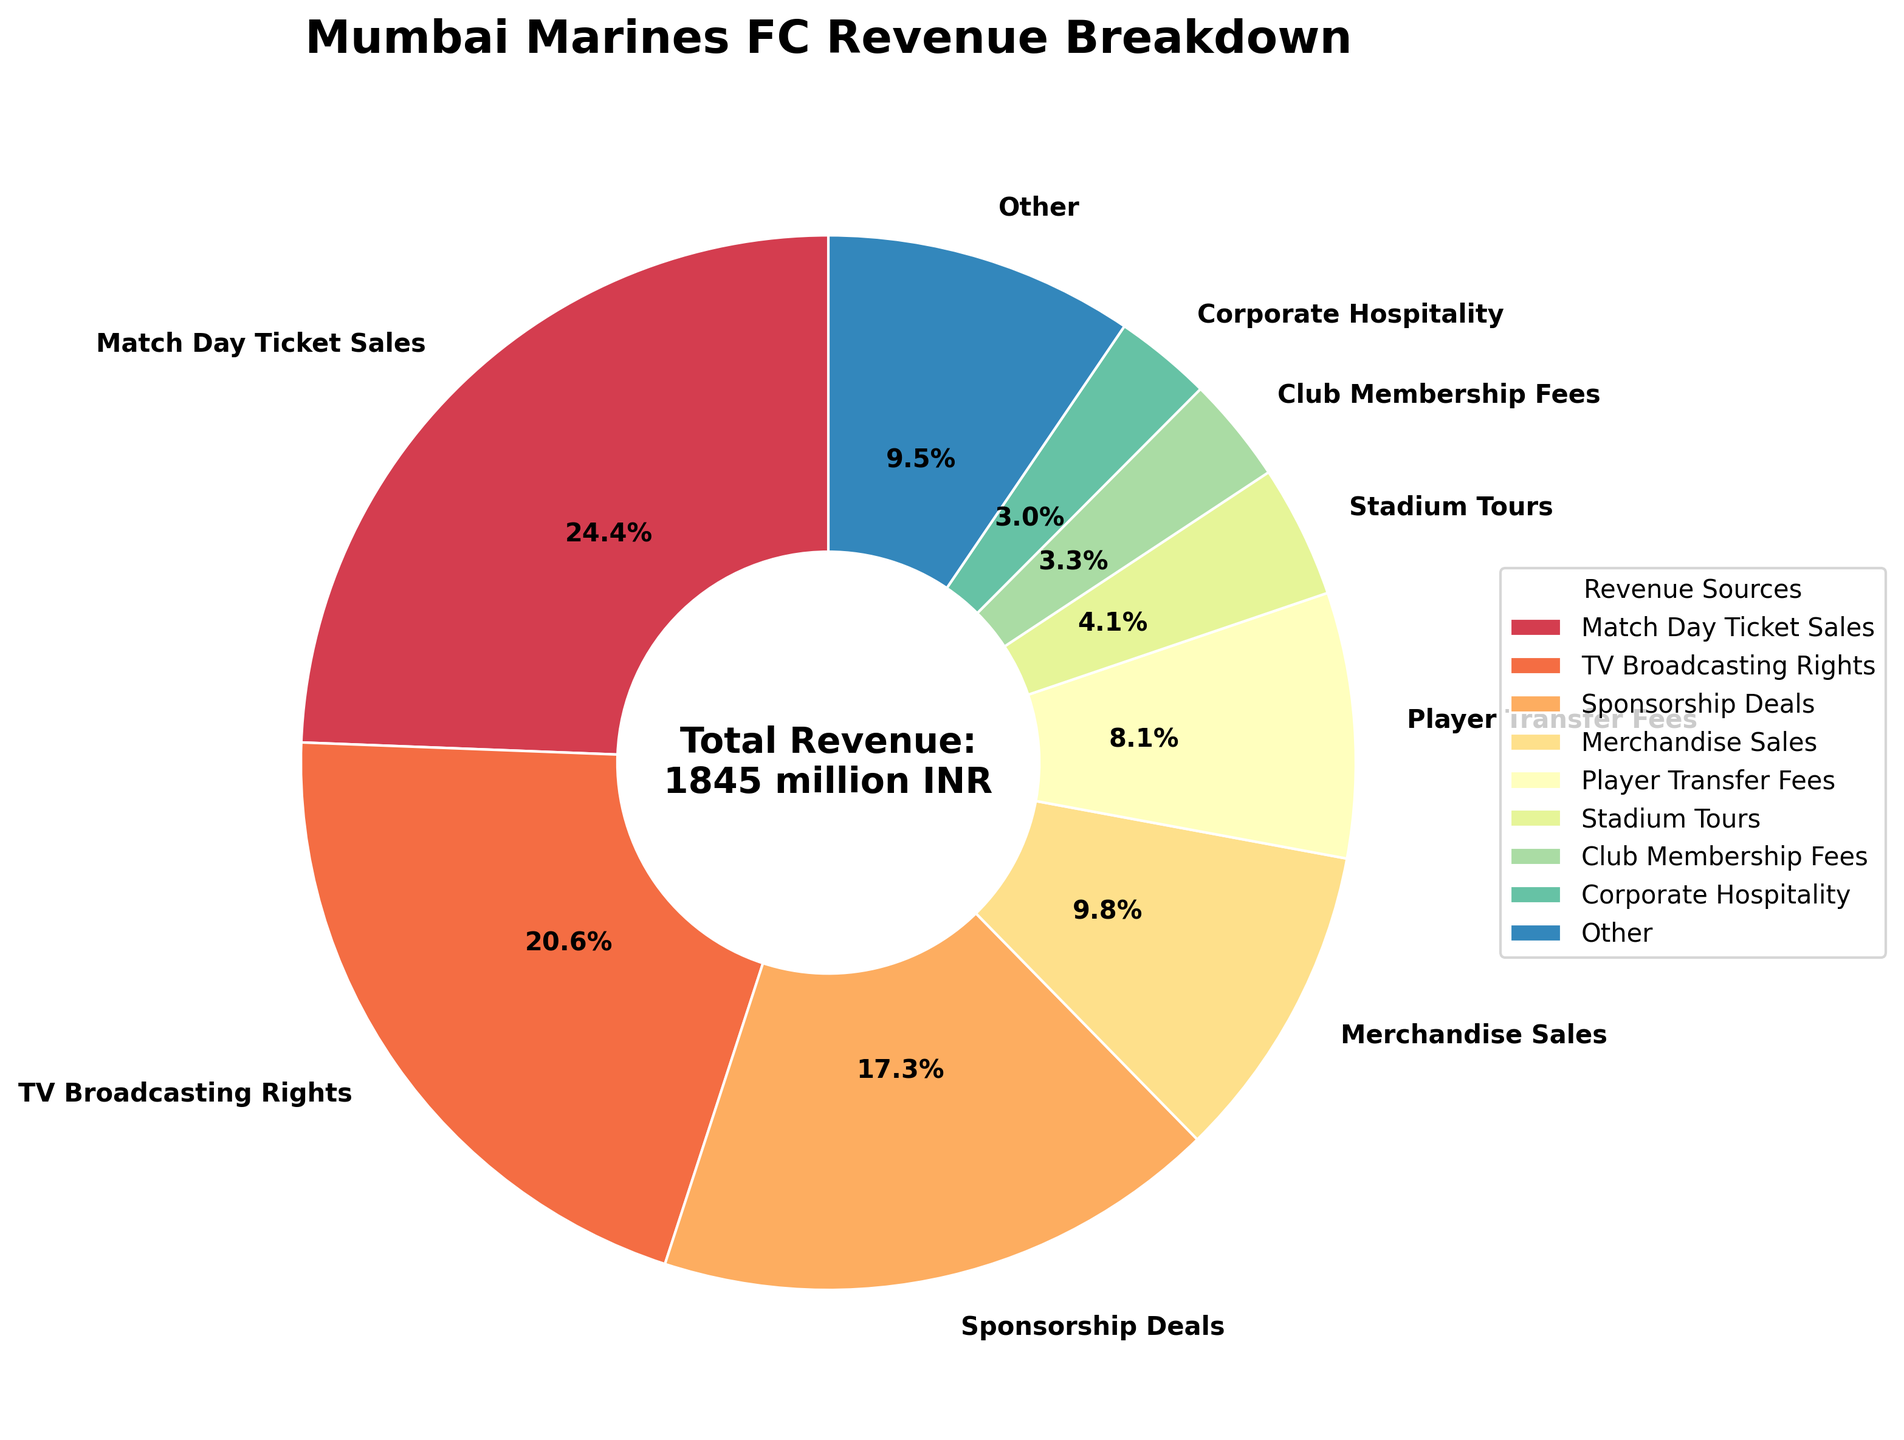Which revenue source contributes the largest percentage? The section with the largest percentage on the pie chart is Match Day Ticket Sales. It occupies the biggest wedge on the pie chart.
Answer: Match Day Ticket Sales Which revenue source has a larger contribution, Merchandise Sales or TV Broadcasting Rights? By comparing their sections on the pie chart, TV Broadcasting Rights has a larger wedge than Merchandise Sales.
Answer: TV Broadcasting Rights What percentage of the total revenue is generated by Social Media Partnerships and Esports Team Revenue combined? Social Media Partnerships contribute 1.8%, and Esports Team Revenue contributes 1.3%. Adding these percentages gives 3.1%.
Answer: 3.1% Are corporate hospitality revenues greater than stadium tours revenues? The section for Corporate Hospitality is smaller than that for Stadium Tours on the pie chart, indicating that Corporate Hospitality revenues are less.
Answer: No Which revenue sources fall in the "Other" category? The "Other" category includes revenue sources with smaller contributions, which are below the top 8. These include Club Membership Fees, Corporate Hospitality, International Pre-season Tours, Mobile App Subscriptions, Youth Academy Revenue, Licensing Agreements, Social Media Partnerships, Esports Team Revenue, and Community Outreach Programs.
Answer: Club Membership Fees, Corporate Hospitality, International Pre-season Tours, Mobile App Subscriptions, Youth Academy Revenue, Licensing Agreements, Social Media Partnerships, Esports Team Revenue, Community Outreach Programs How much total revenue is represented by the top 8 categories? The total revenue of the top 8 categories can be derived from the top 8 segments in the pie chart. Sum the values of Match Day Ticket Sales (450), TV Broadcasting Rights (380), Sponsorship Deals (320), Merchandise Sales (180), Player Transfer Fees (150), Stadium Tours (75), Club Membership Fees (60), and Corporate Hospitality (55). This sums up to 1670 million INR.
Answer: 1670 million INR What's the difference in contribution between the highest revenue source and the lowest revenue source in the pie chart? The largest revenue source is Match Day Ticket Sales (24.5%), and the smallest in the pie chart shown is Esports Team Revenue (0.8%). The difference in percentage contribution is 24.5% - 0.8% = 23.7%.
Answer: 23.7% What is the combined revenue from merchandise sales and stadium tours? Merchandise Sales contribute 180 million INR, and Stadium Tours contribute 75 million INR. Adding these amounts gives 180 + 75 = 255 million INR.
Answer: 255 million INR What visual attribute distinguishes the "Other" section from the top contributors in the pie chart? The "Other" section is visually distinct because it is typically the last wedge in terms of arrangement after the larger, top 8 contributors and often summarized with a different color or pattern.
Answer: Different color Is more revenue generated from Player Transfer Fees or Sponsorship Deals? Sponsorship Deals has a larger segment than Player Transfer Fees on the pie chart, indicating it generates more revenue.
Answer: Sponsorship Deals 